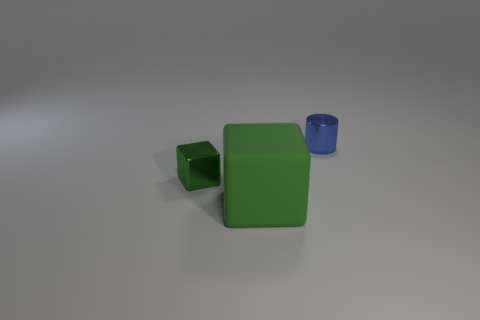Add 2 tiny blue spheres. How many objects exist? 5 Subtract all blocks. How many objects are left? 1 Add 2 green metal cubes. How many green metal cubes are left? 3 Add 3 large gray rubber objects. How many large gray rubber objects exist? 3 Subtract 0 blue cubes. How many objects are left? 3 Subtract all small yellow rubber spheres. Subtract all green things. How many objects are left? 1 